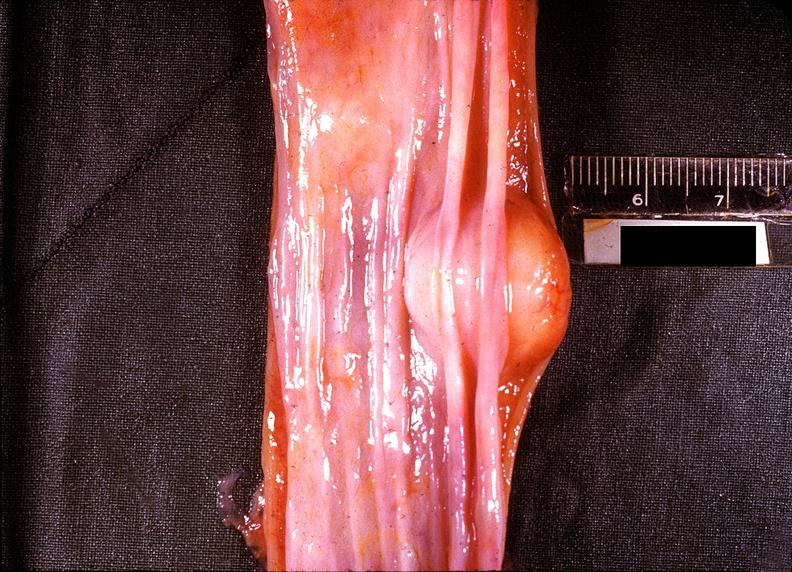does this image show esophagus, leiomyoma?
Answer the question using a single word or phrase. Yes 